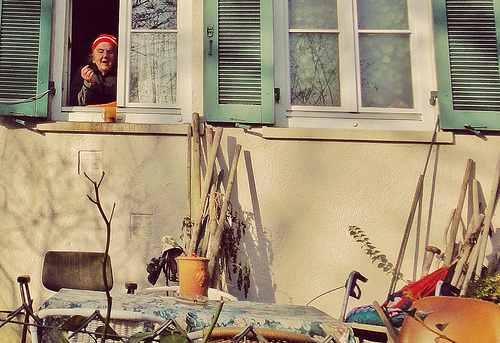<image>
Can you confirm if the chair is to the right of the wood piece? No. The chair is not to the right of the wood piece. The horizontal positioning shows a different relationship. 